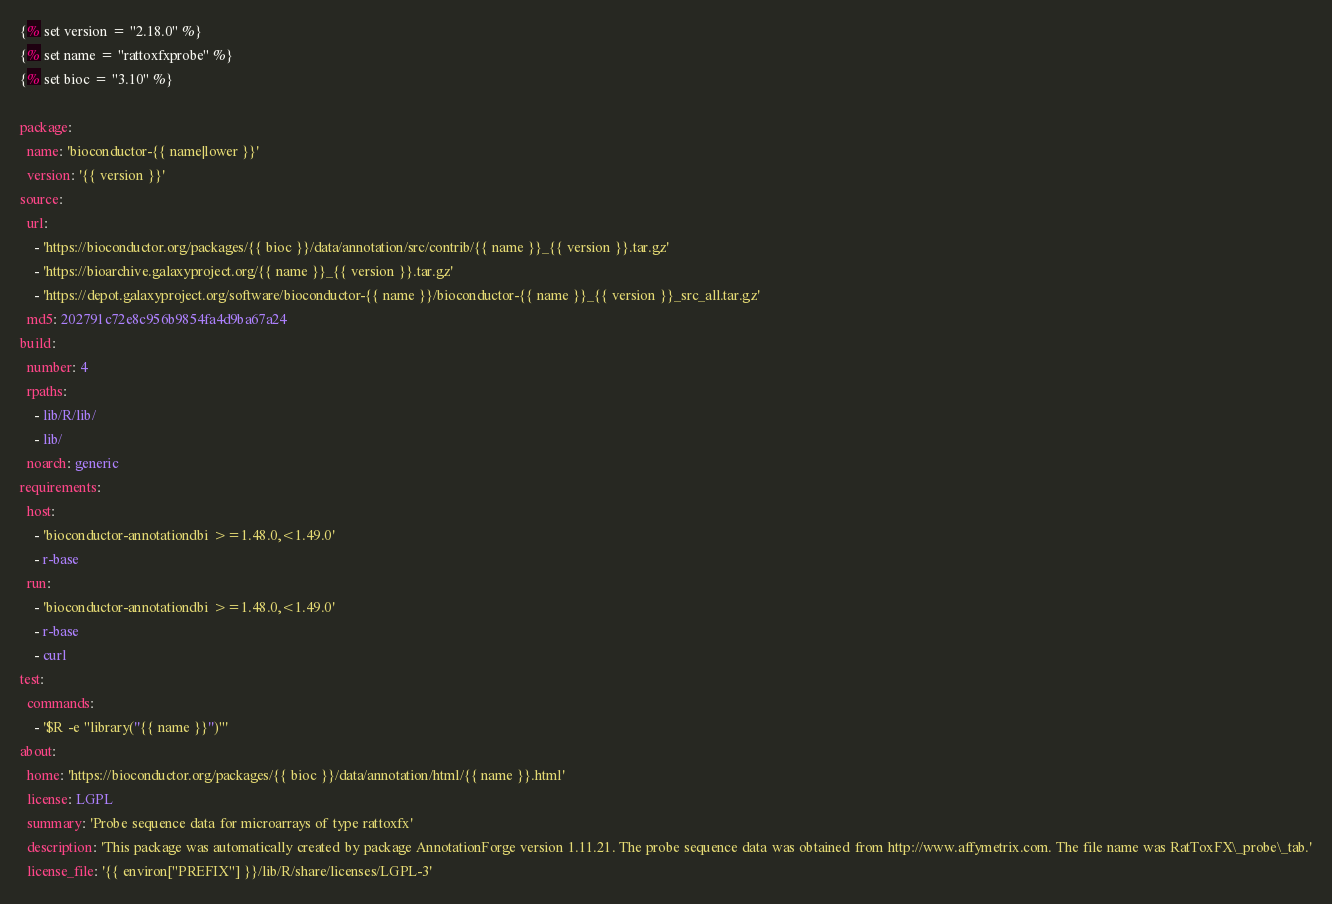Convert code to text. <code><loc_0><loc_0><loc_500><loc_500><_YAML_>{% set version = "2.18.0" %}
{% set name = "rattoxfxprobe" %}
{% set bioc = "3.10" %}

package:
  name: 'bioconductor-{{ name|lower }}'
  version: '{{ version }}'
source:
  url:
    - 'https://bioconductor.org/packages/{{ bioc }}/data/annotation/src/contrib/{{ name }}_{{ version }}.tar.gz'
    - 'https://bioarchive.galaxyproject.org/{{ name }}_{{ version }}.tar.gz'
    - 'https://depot.galaxyproject.org/software/bioconductor-{{ name }}/bioconductor-{{ name }}_{{ version }}_src_all.tar.gz'
  md5: 202791c72e8c956b9854fa4d9ba67a24
build:
  number: 4
  rpaths:
    - lib/R/lib/
    - lib/
  noarch: generic
requirements:
  host:
    - 'bioconductor-annotationdbi >=1.48.0,<1.49.0'
    - r-base
  run:
    - 'bioconductor-annotationdbi >=1.48.0,<1.49.0'
    - r-base
    - curl
test:
  commands:
    - '$R -e "library(''{{ name }}'')"'
about:
  home: 'https://bioconductor.org/packages/{{ bioc }}/data/annotation/html/{{ name }}.html'
  license: LGPL
  summary: 'Probe sequence data for microarrays of type rattoxfx'
  description: 'This package was automatically created by package AnnotationForge version 1.11.21. The probe sequence data was obtained from http://www.affymetrix.com. The file name was RatToxFX\_probe\_tab.'
  license_file: '{{ environ["PREFIX"] }}/lib/R/share/licenses/LGPL-3'

</code> 